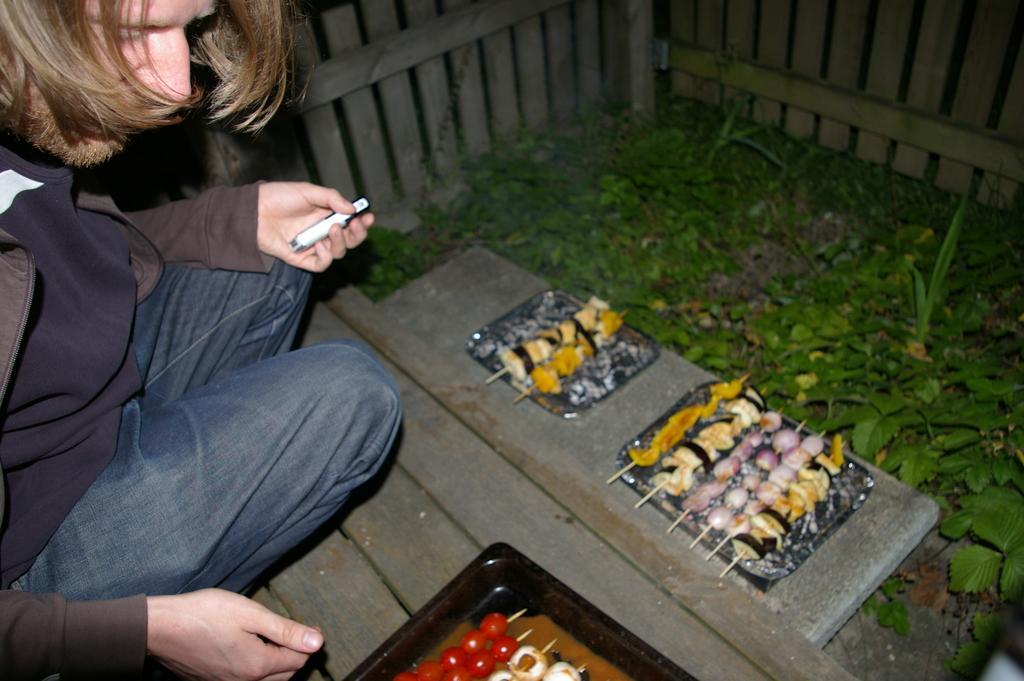Can you describe this image briefly? In this picture we can see a person, trays, and food items. There are plants and a fence. 